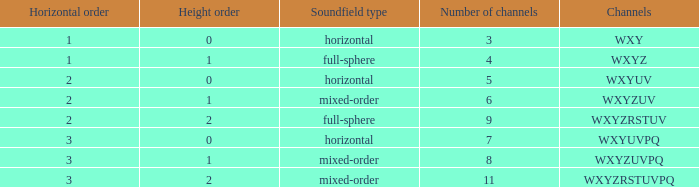If the channels is wxyzrstuvpq, what is the horizontal order? 3.0. Would you be able to parse every entry in this table? {'header': ['Horizontal order', 'Height order', 'Soundfield type', 'Number of channels', 'Channels'], 'rows': [['1', '0', 'horizontal', '3', 'WXY'], ['1', '1', 'full-sphere', '4', 'WXYZ'], ['2', '0', 'horizontal', '5', 'WXYUV'], ['2', '1', 'mixed-order', '6', 'WXYZUV'], ['2', '2', 'full-sphere', '9', 'WXYZRSTUV'], ['3', '0', 'horizontal', '7', 'WXYUVPQ'], ['3', '1', 'mixed-order', '8', 'WXYZUVPQ'], ['3', '2', 'mixed-order', '11', 'WXYZRSTUVPQ']]} 